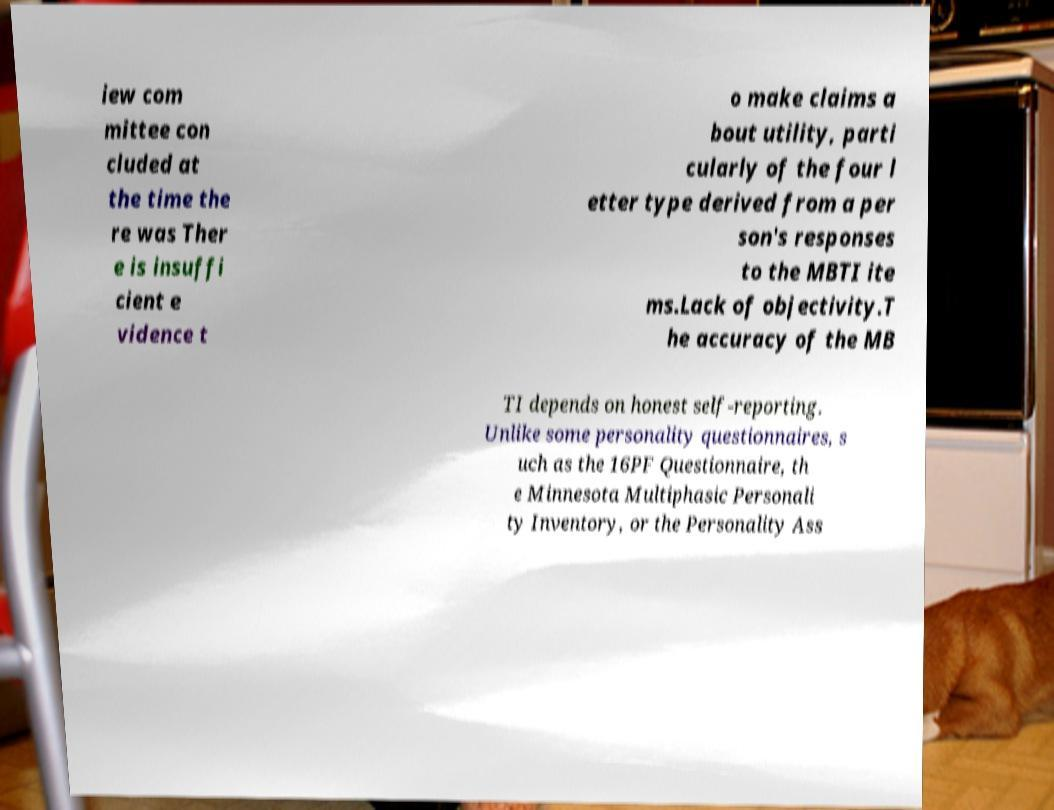Please identify and transcribe the text found in this image. iew com mittee con cluded at the time the re was Ther e is insuffi cient e vidence t o make claims a bout utility, parti cularly of the four l etter type derived from a per son's responses to the MBTI ite ms.Lack of objectivity.T he accuracy of the MB TI depends on honest self-reporting. Unlike some personality questionnaires, s uch as the 16PF Questionnaire, th e Minnesota Multiphasic Personali ty Inventory, or the Personality Ass 